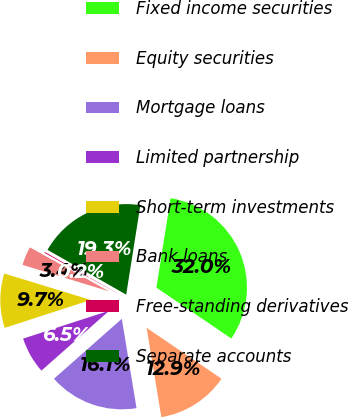<chart> <loc_0><loc_0><loc_500><loc_500><pie_chart><fcel>Fixed income securities<fcel>Equity securities<fcel>Mortgage loans<fcel>Limited partnership<fcel>Short-term investments<fcel>Bank loans<fcel>Free-standing derivatives<fcel>Separate accounts<nl><fcel>32.0%<fcel>12.9%<fcel>16.08%<fcel>6.53%<fcel>9.71%<fcel>3.35%<fcel>0.16%<fcel>19.27%<nl></chart> 